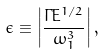<formula> <loc_0><loc_0><loc_500><loc_500>\epsilon \equiv \left | \frac { \Gamma E ^ { 1 / 2 } } { \omega _ { 1 } ^ { 3 } } \right | ,</formula> 